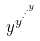Convert formula to latex. <formula><loc_0><loc_0><loc_500><loc_500>y ^ { y ^ { \cdot ^ { \cdot ^ { \cdot ^ { y } } } } }</formula> 